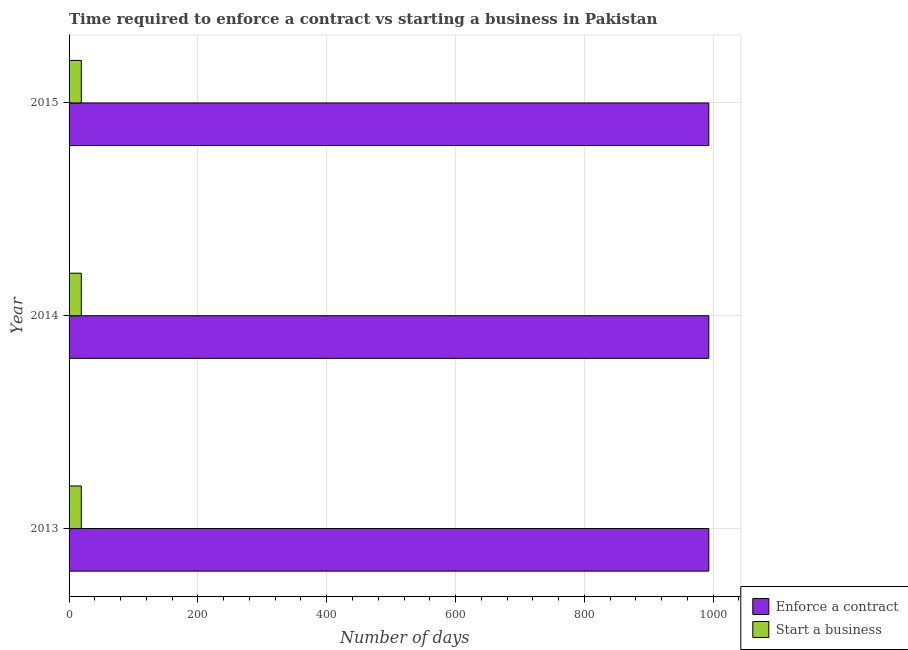How many groups of bars are there?
Your response must be concise. 3. Are the number of bars per tick equal to the number of legend labels?
Provide a short and direct response. Yes. How many bars are there on the 2nd tick from the bottom?
Give a very brief answer. 2. What is the label of the 3rd group of bars from the top?
Provide a succinct answer. 2013. In how many cases, is the number of bars for a given year not equal to the number of legend labels?
Your response must be concise. 0. What is the number of days to start a business in 2014?
Provide a succinct answer. 19. Across all years, what is the maximum number of days to enforece a contract?
Provide a succinct answer. 993.2. Across all years, what is the minimum number of days to start a business?
Ensure brevity in your answer.  19. In which year was the number of days to enforece a contract maximum?
Your answer should be compact. 2013. What is the total number of days to enforece a contract in the graph?
Give a very brief answer. 2979.6. What is the difference between the number of days to start a business in 2013 and that in 2014?
Offer a very short reply. 0. What is the difference between the number of days to start a business in 2015 and the number of days to enforece a contract in 2013?
Ensure brevity in your answer.  -974.2. What is the average number of days to enforece a contract per year?
Provide a short and direct response. 993.2. In the year 2013, what is the difference between the number of days to start a business and number of days to enforece a contract?
Provide a succinct answer. -974.2. In how many years, is the number of days to enforece a contract greater than 520 days?
Your response must be concise. 3. Is the difference between the number of days to enforece a contract in 2013 and 2015 greater than the difference between the number of days to start a business in 2013 and 2015?
Offer a terse response. No. What is the difference between the highest and the lowest number of days to enforece a contract?
Offer a terse response. 0. In how many years, is the number of days to enforece a contract greater than the average number of days to enforece a contract taken over all years?
Ensure brevity in your answer.  0. Is the sum of the number of days to enforece a contract in 2013 and 2015 greater than the maximum number of days to start a business across all years?
Give a very brief answer. Yes. What does the 2nd bar from the top in 2013 represents?
Ensure brevity in your answer.  Enforce a contract. What does the 2nd bar from the bottom in 2015 represents?
Give a very brief answer. Start a business. Are all the bars in the graph horizontal?
Provide a short and direct response. Yes. Are the values on the major ticks of X-axis written in scientific E-notation?
Provide a succinct answer. No. Does the graph contain any zero values?
Provide a succinct answer. No. Where does the legend appear in the graph?
Your response must be concise. Bottom right. What is the title of the graph?
Provide a succinct answer. Time required to enforce a contract vs starting a business in Pakistan. What is the label or title of the X-axis?
Ensure brevity in your answer.  Number of days. What is the label or title of the Y-axis?
Offer a terse response. Year. What is the Number of days in Enforce a contract in 2013?
Ensure brevity in your answer.  993.2. What is the Number of days in Start a business in 2013?
Your answer should be very brief. 19. What is the Number of days of Enforce a contract in 2014?
Provide a short and direct response. 993.2. What is the Number of days of Enforce a contract in 2015?
Make the answer very short. 993.2. What is the Number of days of Start a business in 2015?
Make the answer very short. 19. Across all years, what is the maximum Number of days in Enforce a contract?
Provide a succinct answer. 993.2. Across all years, what is the minimum Number of days of Enforce a contract?
Make the answer very short. 993.2. Across all years, what is the minimum Number of days of Start a business?
Offer a very short reply. 19. What is the total Number of days in Enforce a contract in the graph?
Provide a succinct answer. 2979.6. What is the difference between the Number of days in Enforce a contract in 2013 and the Number of days in Start a business in 2014?
Give a very brief answer. 974.2. What is the difference between the Number of days in Enforce a contract in 2013 and the Number of days in Start a business in 2015?
Your response must be concise. 974.2. What is the difference between the Number of days of Enforce a contract in 2014 and the Number of days of Start a business in 2015?
Your answer should be very brief. 974.2. What is the average Number of days of Enforce a contract per year?
Provide a succinct answer. 993.2. In the year 2013, what is the difference between the Number of days of Enforce a contract and Number of days of Start a business?
Provide a succinct answer. 974.2. In the year 2014, what is the difference between the Number of days in Enforce a contract and Number of days in Start a business?
Keep it short and to the point. 974.2. In the year 2015, what is the difference between the Number of days of Enforce a contract and Number of days of Start a business?
Your answer should be very brief. 974.2. What is the ratio of the Number of days in Enforce a contract in 2013 to that in 2014?
Your answer should be compact. 1. What is the ratio of the Number of days in Enforce a contract in 2013 to that in 2015?
Keep it short and to the point. 1. What is the ratio of the Number of days of Start a business in 2013 to that in 2015?
Give a very brief answer. 1. What is the ratio of the Number of days in Enforce a contract in 2014 to that in 2015?
Keep it short and to the point. 1. What is the difference between the highest and the lowest Number of days of Enforce a contract?
Your response must be concise. 0. 